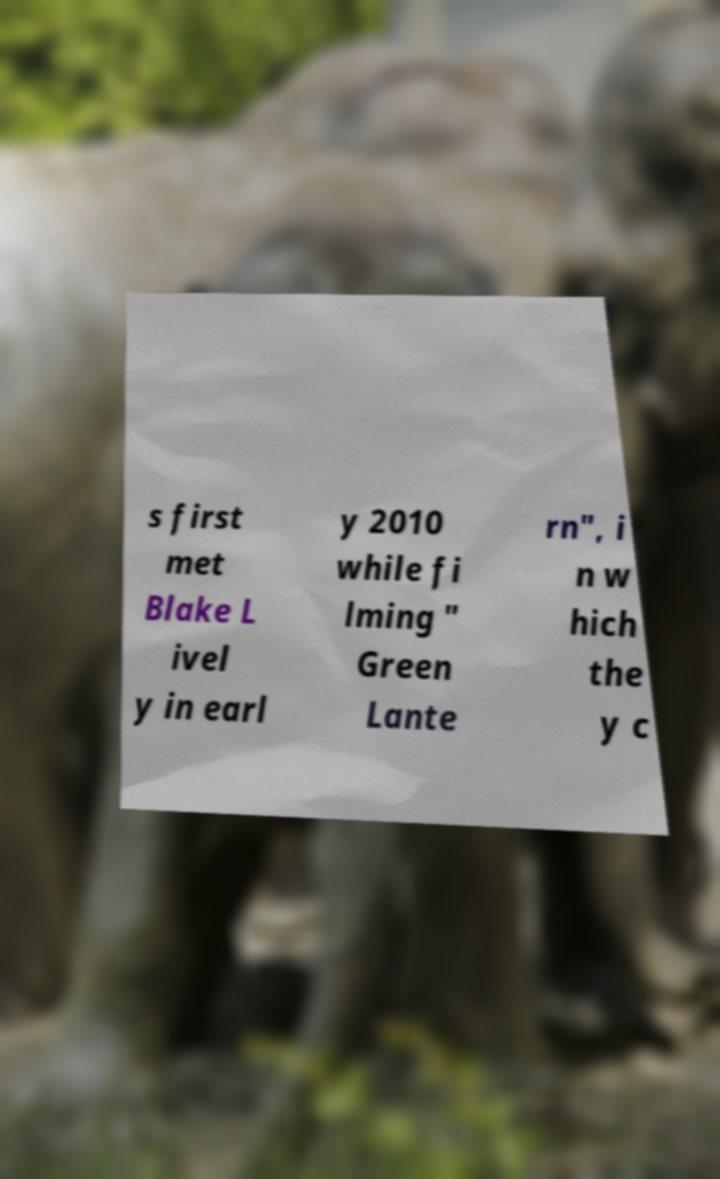Can you read and provide the text displayed in the image?This photo seems to have some interesting text. Can you extract and type it out for me? s first met Blake L ivel y in earl y 2010 while fi lming " Green Lante rn", i n w hich the y c 